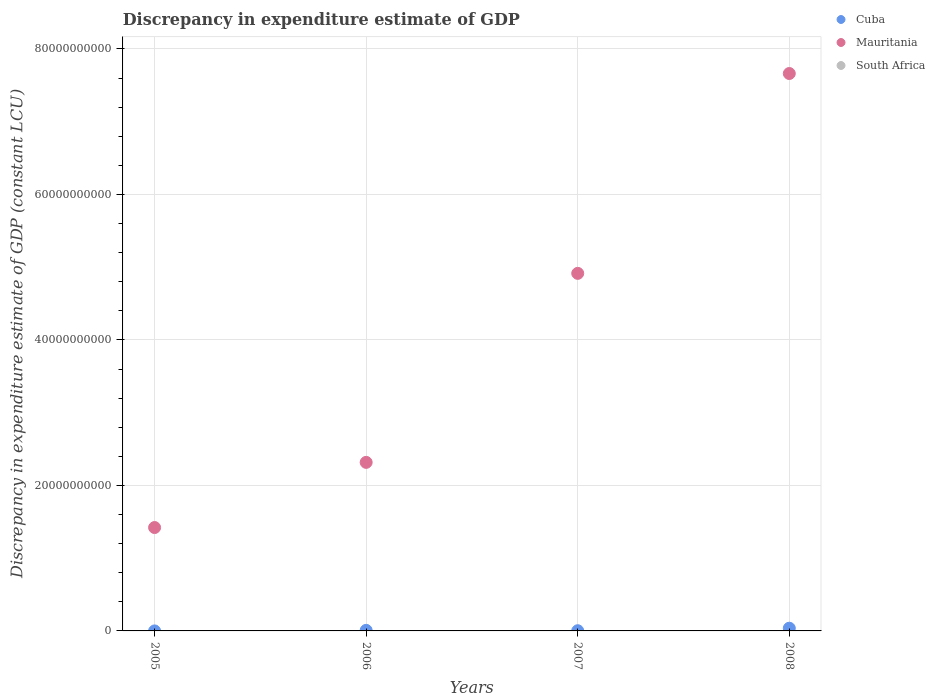How many different coloured dotlines are there?
Make the answer very short. 2. Is the number of dotlines equal to the number of legend labels?
Your answer should be compact. No. Across all years, what is the maximum discrepancy in expenditure estimate of GDP in Mauritania?
Offer a terse response. 7.66e+1. What is the total discrepancy in expenditure estimate of GDP in Mauritania in the graph?
Keep it short and to the point. 1.63e+11. What is the difference between the discrepancy in expenditure estimate of GDP in Mauritania in 2007 and that in 2008?
Your answer should be compact. -2.75e+1. What is the difference between the discrepancy in expenditure estimate of GDP in South Africa in 2008 and the discrepancy in expenditure estimate of GDP in Cuba in 2007?
Give a very brief answer. -2.78e+07. What is the average discrepancy in expenditure estimate of GDP in Mauritania per year?
Your answer should be very brief. 4.08e+1. In the year 2005, what is the difference between the discrepancy in expenditure estimate of GDP in Cuba and discrepancy in expenditure estimate of GDP in Mauritania?
Offer a very short reply. -1.42e+1. In how many years, is the discrepancy in expenditure estimate of GDP in Mauritania greater than 60000000000 LCU?
Provide a succinct answer. 1. What is the ratio of the discrepancy in expenditure estimate of GDP in Mauritania in 2006 to that in 2008?
Offer a very short reply. 0.3. Is the difference between the discrepancy in expenditure estimate of GDP in Cuba in 2006 and 2007 greater than the difference between the discrepancy in expenditure estimate of GDP in Mauritania in 2006 and 2007?
Your answer should be very brief. Yes. What is the difference between the highest and the second highest discrepancy in expenditure estimate of GDP in Mauritania?
Ensure brevity in your answer.  2.75e+1. What is the difference between the highest and the lowest discrepancy in expenditure estimate of GDP in Mauritania?
Keep it short and to the point. 6.24e+1. Is the sum of the discrepancy in expenditure estimate of GDP in Cuba in 2007 and 2008 greater than the maximum discrepancy in expenditure estimate of GDP in Mauritania across all years?
Make the answer very short. No. How many dotlines are there?
Your answer should be compact. 2. Does the graph contain any zero values?
Your answer should be very brief. Yes. Does the graph contain grids?
Make the answer very short. Yes. Where does the legend appear in the graph?
Offer a very short reply. Top right. How many legend labels are there?
Your answer should be very brief. 3. What is the title of the graph?
Offer a very short reply. Discrepancy in expenditure estimate of GDP. Does "North America" appear as one of the legend labels in the graph?
Make the answer very short. No. What is the label or title of the Y-axis?
Give a very brief answer. Discrepancy in expenditure estimate of GDP (constant LCU). What is the Discrepancy in expenditure estimate of GDP (constant LCU) in Mauritania in 2005?
Ensure brevity in your answer.  1.42e+1. What is the Discrepancy in expenditure estimate of GDP (constant LCU) in South Africa in 2005?
Make the answer very short. 0. What is the Discrepancy in expenditure estimate of GDP (constant LCU) of Cuba in 2006?
Your response must be concise. 7.89e+07. What is the Discrepancy in expenditure estimate of GDP (constant LCU) of Mauritania in 2006?
Ensure brevity in your answer.  2.32e+1. What is the Discrepancy in expenditure estimate of GDP (constant LCU) of South Africa in 2006?
Ensure brevity in your answer.  0. What is the Discrepancy in expenditure estimate of GDP (constant LCU) of Cuba in 2007?
Keep it short and to the point. 2.78e+07. What is the Discrepancy in expenditure estimate of GDP (constant LCU) of Mauritania in 2007?
Keep it short and to the point. 4.92e+1. What is the Discrepancy in expenditure estimate of GDP (constant LCU) in Cuba in 2008?
Give a very brief answer. 3.73e+08. What is the Discrepancy in expenditure estimate of GDP (constant LCU) in Mauritania in 2008?
Offer a terse response. 7.66e+1. Across all years, what is the maximum Discrepancy in expenditure estimate of GDP (constant LCU) in Cuba?
Provide a short and direct response. 3.73e+08. Across all years, what is the maximum Discrepancy in expenditure estimate of GDP (constant LCU) in Mauritania?
Offer a very short reply. 7.66e+1. Across all years, what is the minimum Discrepancy in expenditure estimate of GDP (constant LCU) in Mauritania?
Provide a short and direct response. 1.42e+1. What is the total Discrepancy in expenditure estimate of GDP (constant LCU) of Cuba in the graph?
Offer a very short reply. 4.81e+08. What is the total Discrepancy in expenditure estimate of GDP (constant LCU) of Mauritania in the graph?
Offer a very short reply. 1.63e+11. What is the difference between the Discrepancy in expenditure estimate of GDP (constant LCU) in Cuba in 2005 and that in 2006?
Provide a succinct answer. -7.80e+07. What is the difference between the Discrepancy in expenditure estimate of GDP (constant LCU) in Mauritania in 2005 and that in 2006?
Keep it short and to the point. -8.96e+09. What is the difference between the Discrepancy in expenditure estimate of GDP (constant LCU) in Cuba in 2005 and that in 2007?
Offer a very short reply. -2.69e+07. What is the difference between the Discrepancy in expenditure estimate of GDP (constant LCU) of Mauritania in 2005 and that in 2007?
Your answer should be compact. -3.49e+1. What is the difference between the Discrepancy in expenditure estimate of GDP (constant LCU) of Cuba in 2005 and that in 2008?
Provide a short and direct response. -3.72e+08. What is the difference between the Discrepancy in expenditure estimate of GDP (constant LCU) in Mauritania in 2005 and that in 2008?
Provide a succinct answer. -6.24e+1. What is the difference between the Discrepancy in expenditure estimate of GDP (constant LCU) of Cuba in 2006 and that in 2007?
Keep it short and to the point. 5.11e+07. What is the difference between the Discrepancy in expenditure estimate of GDP (constant LCU) in Mauritania in 2006 and that in 2007?
Your answer should be compact. -2.60e+1. What is the difference between the Discrepancy in expenditure estimate of GDP (constant LCU) of Cuba in 2006 and that in 2008?
Provide a succinct answer. -2.94e+08. What is the difference between the Discrepancy in expenditure estimate of GDP (constant LCU) in Mauritania in 2006 and that in 2008?
Your answer should be compact. -5.35e+1. What is the difference between the Discrepancy in expenditure estimate of GDP (constant LCU) of Cuba in 2007 and that in 2008?
Make the answer very short. -3.45e+08. What is the difference between the Discrepancy in expenditure estimate of GDP (constant LCU) in Mauritania in 2007 and that in 2008?
Your answer should be compact. -2.75e+1. What is the difference between the Discrepancy in expenditure estimate of GDP (constant LCU) of Cuba in 2005 and the Discrepancy in expenditure estimate of GDP (constant LCU) of Mauritania in 2006?
Provide a short and direct response. -2.32e+1. What is the difference between the Discrepancy in expenditure estimate of GDP (constant LCU) of Cuba in 2005 and the Discrepancy in expenditure estimate of GDP (constant LCU) of Mauritania in 2007?
Give a very brief answer. -4.92e+1. What is the difference between the Discrepancy in expenditure estimate of GDP (constant LCU) in Cuba in 2005 and the Discrepancy in expenditure estimate of GDP (constant LCU) in Mauritania in 2008?
Provide a short and direct response. -7.66e+1. What is the difference between the Discrepancy in expenditure estimate of GDP (constant LCU) of Cuba in 2006 and the Discrepancy in expenditure estimate of GDP (constant LCU) of Mauritania in 2007?
Your answer should be compact. -4.91e+1. What is the difference between the Discrepancy in expenditure estimate of GDP (constant LCU) in Cuba in 2006 and the Discrepancy in expenditure estimate of GDP (constant LCU) in Mauritania in 2008?
Make the answer very short. -7.65e+1. What is the difference between the Discrepancy in expenditure estimate of GDP (constant LCU) in Cuba in 2007 and the Discrepancy in expenditure estimate of GDP (constant LCU) in Mauritania in 2008?
Ensure brevity in your answer.  -7.66e+1. What is the average Discrepancy in expenditure estimate of GDP (constant LCU) of Cuba per year?
Ensure brevity in your answer.  1.20e+08. What is the average Discrepancy in expenditure estimate of GDP (constant LCU) of Mauritania per year?
Provide a succinct answer. 4.08e+1. In the year 2005, what is the difference between the Discrepancy in expenditure estimate of GDP (constant LCU) in Cuba and Discrepancy in expenditure estimate of GDP (constant LCU) in Mauritania?
Your response must be concise. -1.42e+1. In the year 2006, what is the difference between the Discrepancy in expenditure estimate of GDP (constant LCU) of Cuba and Discrepancy in expenditure estimate of GDP (constant LCU) of Mauritania?
Offer a terse response. -2.31e+1. In the year 2007, what is the difference between the Discrepancy in expenditure estimate of GDP (constant LCU) in Cuba and Discrepancy in expenditure estimate of GDP (constant LCU) in Mauritania?
Your answer should be very brief. -4.91e+1. In the year 2008, what is the difference between the Discrepancy in expenditure estimate of GDP (constant LCU) in Cuba and Discrepancy in expenditure estimate of GDP (constant LCU) in Mauritania?
Your response must be concise. -7.63e+1. What is the ratio of the Discrepancy in expenditure estimate of GDP (constant LCU) of Cuba in 2005 to that in 2006?
Offer a very short reply. 0.01. What is the ratio of the Discrepancy in expenditure estimate of GDP (constant LCU) of Mauritania in 2005 to that in 2006?
Your answer should be very brief. 0.61. What is the ratio of the Discrepancy in expenditure estimate of GDP (constant LCU) of Cuba in 2005 to that in 2007?
Give a very brief answer. 0.03. What is the ratio of the Discrepancy in expenditure estimate of GDP (constant LCU) in Mauritania in 2005 to that in 2007?
Provide a short and direct response. 0.29. What is the ratio of the Discrepancy in expenditure estimate of GDP (constant LCU) of Cuba in 2005 to that in 2008?
Make the answer very short. 0. What is the ratio of the Discrepancy in expenditure estimate of GDP (constant LCU) of Mauritania in 2005 to that in 2008?
Make the answer very short. 0.19. What is the ratio of the Discrepancy in expenditure estimate of GDP (constant LCU) in Cuba in 2006 to that in 2007?
Provide a short and direct response. 2.84. What is the ratio of the Discrepancy in expenditure estimate of GDP (constant LCU) of Mauritania in 2006 to that in 2007?
Provide a short and direct response. 0.47. What is the ratio of the Discrepancy in expenditure estimate of GDP (constant LCU) of Cuba in 2006 to that in 2008?
Provide a succinct answer. 0.21. What is the ratio of the Discrepancy in expenditure estimate of GDP (constant LCU) of Mauritania in 2006 to that in 2008?
Your response must be concise. 0.3. What is the ratio of the Discrepancy in expenditure estimate of GDP (constant LCU) of Cuba in 2007 to that in 2008?
Your answer should be very brief. 0.07. What is the ratio of the Discrepancy in expenditure estimate of GDP (constant LCU) in Mauritania in 2007 to that in 2008?
Provide a succinct answer. 0.64. What is the difference between the highest and the second highest Discrepancy in expenditure estimate of GDP (constant LCU) of Cuba?
Give a very brief answer. 2.94e+08. What is the difference between the highest and the second highest Discrepancy in expenditure estimate of GDP (constant LCU) of Mauritania?
Keep it short and to the point. 2.75e+1. What is the difference between the highest and the lowest Discrepancy in expenditure estimate of GDP (constant LCU) of Cuba?
Your response must be concise. 3.72e+08. What is the difference between the highest and the lowest Discrepancy in expenditure estimate of GDP (constant LCU) of Mauritania?
Make the answer very short. 6.24e+1. 